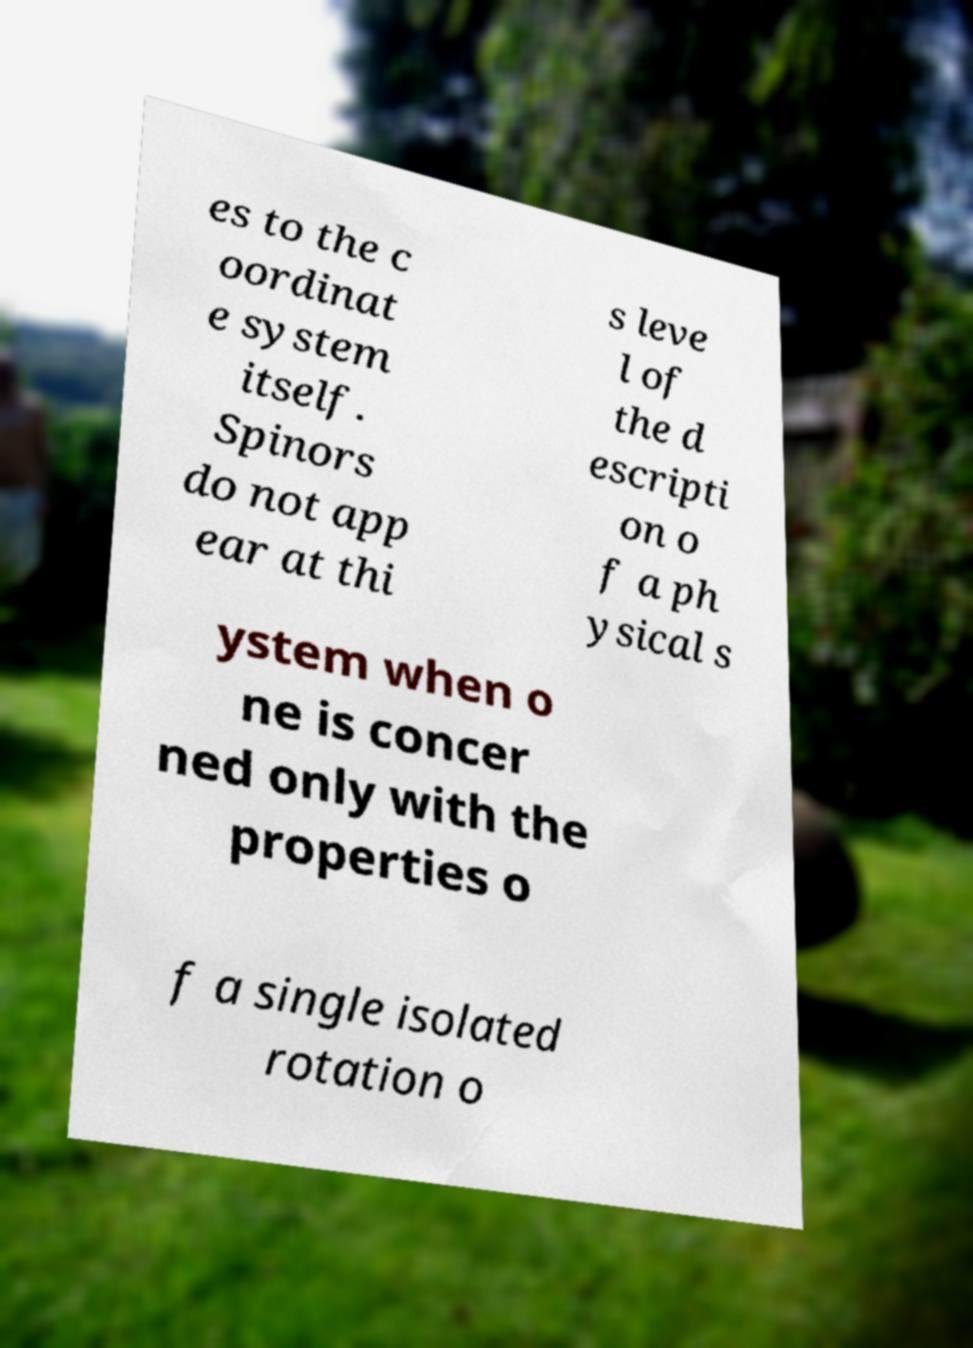There's text embedded in this image that I need extracted. Can you transcribe it verbatim? es to the c oordinat e system itself. Spinors do not app ear at thi s leve l of the d escripti on o f a ph ysical s ystem when o ne is concer ned only with the properties o f a single isolated rotation o 